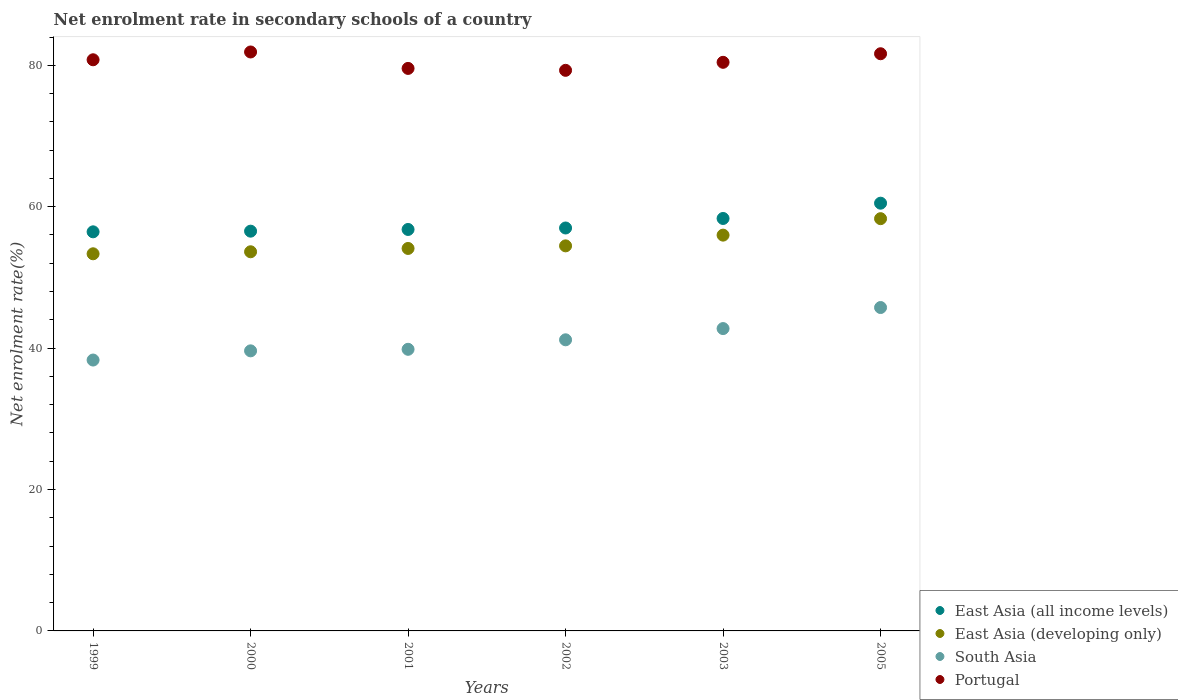How many different coloured dotlines are there?
Offer a terse response. 4. Is the number of dotlines equal to the number of legend labels?
Keep it short and to the point. Yes. What is the net enrolment rate in secondary schools in East Asia (developing only) in 2002?
Provide a succinct answer. 54.46. Across all years, what is the maximum net enrolment rate in secondary schools in East Asia (all income levels)?
Provide a short and direct response. 60.5. Across all years, what is the minimum net enrolment rate in secondary schools in East Asia (all income levels)?
Keep it short and to the point. 56.45. In which year was the net enrolment rate in secondary schools in East Asia (developing only) maximum?
Provide a short and direct response. 2005. What is the total net enrolment rate in secondary schools in South Asia in the graph?
Your answer should be very brief. 247.44. What is the difference between the net enrolment rate in secondary schools in South Asia in 1999 and that in 2005?
Ensure brevity in your answer.  -7.43. What is the difference between the net enrolment rate in secondary schools in East Asia (developing only) in 2002 and the net enrolment rate in secondary schools in East Asia (all income levels) in 2000?
Provide a short and direct response. -2.08. What is the average net enrolment rate in secondary schools in East Asia (developing only) per year?
Make the answer very short. 54.97. In the year 2000, what is the difference between the net enrolment rate in secondary schools in East Asia (developing only) and net enrolment rate in secondary schools in South Asia?
Keep it short and to the point. 14.01. What is the ratio of the net enrolment rate in secondary schools in Portugal in 2001 to that in 2002?
Your answer should be very brief. 1. Is the net enrolment rate in secondary schools in East Asia (developing only) in 2000 less than that in 2002?
Offer a terse response. Yes. Is the difference between the net enrolment rate in secondary schools in East Asia (developing only) in 2000 and 2002 greater than the difference between the net enrolment rate in secondary schools in South Asia in 2000 and 2002?
Provide a succinct answer. Yes. What is the difference between the highest and the second highest net enrolment rate in secondary schools in South Asia?
Ensure brevity in your answer.  2.98. What is the difference between the highest and the lowest net enrolment rate in secondary schools in South Asia?
Provide a short and direct response. 7.43. Is the sum of the net enrolment rate in secondary schools in East Asia (all income levels) in 2001 and 2003 greater than the maximum net enrolment rate in secondary schools in East Asia (developing only) across all years?
Offer a terse response. Yes. Is it the case that in every year, the sum of the net enrolment rate in secondary schools in Portugal and net enrolment rate in secondary schools in South Asia  is greater than the net enrolment rate in secondary schools in East Asia (all income levels)?
Offer a very short reply. Yes. Does the net enrolment rate in secondary schools in South Asia monotonically increase over the years?
Your answer should be compact. Yes. How many dotlines are there?
Provide a short and direct response. 4. How many years are there in the graph?
Keep it short and to the point. 6. Where does the legend appear in the graph?
Provide a succinct answer. Bottom right. What is the title of the graph?
Your answer should be very brief. Net enrolment rate in secondary schools of a country. Does "Middle East & North Africa (all income levels)" appear as one of the legend labels in the graph?
Offer a very short reply. No. What is the label or title of the Y-axis?
Offer a very short reply. Net enrolment rate(%). What is the Net enrolment rate(%) of East Asia (all income levels) in 1999?
Provide a succinct answer. 56.45. What is the Net enrolment rate(%) in East Asia (developing only) in 1999?
Your response must be concise. 53.34. What is the Net enrolment rate(%) in South Asia in 1999?
Your answer should be compact. 38.31. What is the Net enrolment rate(%) of Portugal in 1999?
Offer a very short reply. 80.78. What is the Net enrolment rate(%) of East Asia (all income levels) in 2000?
Give a very brief answer. 56.54. What is the Net enrolment rate(%) of East Asia (developing only) in 2000?
Provide a short and direct response. 53.63. What is the Net enrolment rate(%) of South Asia in 2000?
Make the answer very short. 39.61. What is the Net enrolment rate(%) in Portugal in 2000?
Provide a short and direct response. 81.89. What is the Net enrolment rate(%) in East Asia (all income levels) in 2001?
Your answer should be very brief. 56.78. What is the Net enrolment rate(%) in East Asia (developing only) in 2001?
Offer a terse response. 54.1. What is the Net enrolment rate(%) of South Asia in 2001?
Provide a short and direct response. 39.83. What is the Net enrolment rate(%) of Portugal in 2001?
Your answer should be compact. 79.56. What is the Net enrolment rate(%) in East Asia (all income levels) in 2002?
Your answer should be very brief. 56.99. What is the Net enrolment rate(%) in East Asia (developing only) in 2002?
Offer a very short reply. 54.46. What is the Net enrolment rate(%) in South Asia in 2002?
Ensure brevity in your answer.  41.18. What is the Net enrolment rate(%) of Portugal in 2002?
Offer a terse response. 79.29. What is the Net enrolment rate(%) in East Asia (all income levels) in 2003?
Keep it short and to the point. 58.34. What is the Net enrolment rate(%) in East Asia (developing only) in 2003?
Your answer should be very brief. 55.98. What is the Net enrolment rate(%) in South Asia in 2003?
Provide a succinct answer. 42.76. What is the Net enrolment rate(%) of Portugal in 2003?
Provide a succinct answer. 80.42. What is the Net enrolment rate(%) of East Asia (all income levels) in 2005?
Your response must be concise. 60.5. What is the Net enrolment rate(%) in East Asia (developing only) in 2005?
Your answer should be very brief. 58.31. What is the Net enrolment rate(%) in South Asia in 2005?
Ensure brevity in your answer.  45.74. What is the Net enrolment rate(%) of Portugal in 2005?
Provide a short and direct response. 81.64. Across all years, what is the maximum Net enrolment rate(%) in East Asia (all income levels)?
Keep it short and to the point. 60.5. Across all years, what is the maximum Net enrolment rate(%) in East Asia (developing only)?
Ensure brevity in your answer.  58.31. Across all years, what is the maximum Net enrolment rate(%) of South Asia?
Ensure brevity in your answer.  45.74. Across all years, what is the maximum Net enrolment rate(%) in Portugal?
Make the answer very short. 81.89. Across all years, what is the minimum Net enrolment rate(%) in East Asia (all income levels)?
Offer a very short reply. 56.45. Across all years, what is the minimum Net enrolment rate(%) of East Asia (developing only)?
Keep it short and to the point. 53.34. Across all years, what is the minimum Net enrolment rate(%) in South Asia?
Provide a short and direct response. 38.31. Across all years, what is the minimum Net enrolment rate(%) in Portugal?
Ensure brevity in your answer.  79.29. What is the total Net enrolment rate(%) in East Asia (all income levels) in the graph?
Offer a very short reply. 345.6. What is the total Net enrolment rate(%) in East Asia (developing only) in the graph?
Provide a succinct answer. 329.82. What is the total Net enrolment rate(%) in South Asia in the graph?
Offer a very short reply. 247.44. What is the total Net enrolment rate(%) in Portugal in the graph?
Keep it short and to the point. 483.58. What is the difference between the Net enrolment rate(%) of East Asia (all income levels) in 1999 and that in 2000?
Provide a succinct answer. -0.09. What is the difference between the Net enrolment rate(%) in East Asia (developing only) in 1999 and that in 2000?
Offer a terse response. -0.29. What is the difference between the Net enrolment rate(%) in South Asia in 1999 and that in 2000?
Your response must be concise. -1.3. What is the difference between the Net enrolment rate(%) in Portugal in 1999 and that in 2000?
Make the answer very short. -1.1. What is the difference between the Net enrolment rate(%) in East Asia (all income levels) in 1999 and that in 2001?
Provide a short and direct response. -0.33. What is the difference between the Net enrolment rate(%) in East Asia (developing only) in 1999 and that in 2001?
Give a very brief answer. -0.76. What is the difference between the Net enrolment rate(%) of South Asia in 1999 and that in 2001?
Your response must be concise. -1.52. What is the difference between the Net enrolment rate(%) of Portugal in 1999 and that in 2001?
Give a very brief answer. 1.22. What is the difference between the Net enrolment rate(%) of East Asia (all income levels) in 1999 and that in 2002?
Ensure brevity in your answer.  -0.54. What is the difference between the Net enrolment rate(%) of East Asia (developing only) in 1999 and that in 2002?
Your response must be concise. -1.12. What is the difference between the Net enrolment rate(%) of South Asia in 1999 and that in 2002?
Provide a short and direct response. -2.86. What is the difference between the Net enrolment rate(%) in Portugal in 1999 and that in 2002?
Give a very brief answer. 1.49. What is the difference between the Net enrolment rate(%) of East Asia (all income levels) in 1999 and that in 2003?
Offer a very short reply. -1.89. What is the difference between the Net enrolment rate(%) in East Asia (developing only) in 1999 and that in 2003?
Your answer should be very brief. -2.64. What is the difference between the Net enrolment rate(%) of South Asia in 1999 and that in 2003?
Your answer should be compact. -4.45. What is the difference between the Net enrolment rate(%) in Portugal in 1999 and that in 2003?
Give a very brief answer. 0.36. What is the difference between the Net enrolment rate(%) in East Asia (all income levels) in 1999 and that in 2005?
Your response must be concise. -4.05. What is the difference between the Net enrolment rate(%) of East Asia (developing only) in 1999 and that in 2005?
Offer a very short reply. -4.97. What is the difference between the Net enrolment rate(%) in South Asia in 1999 and that in 2005?
Provide a succinct answer. -7.43. What is the difference between the Net enrolment rate(%) of Portugal in 1999 and that in 2005?
Your answer should be very brief. -0.85. What is the difference between the Net enrolment rate(%) of East Asia (all income levels) in 2000 and that in 2001?
Provide a short and direct response. -0.24. What is the difference between the Net enrolment rate(%) of East Asia (developing only) in 2000 and that in 2001?
Offer a very short reply. -0.47. What is the difference between the Net enrolment rate(%) of South Asia in 2000 and that in 2001?
Keep it short and to the point. -0.22. What is the difference between the Net enrolment rate(%) of Portugal in 2000 and that in 2001?
Your answer should be compact. 2.33. What is the difference between the Net enrolment rate(%) in East Asia (all income levels) in 2000 and that in 2002?
Keep it short and to the point. -0.45. What is the difference between the Net enrolment rate(%) in East Asia (developing only) in 2000 and that in 2002?
Your response must be concise. -0.84. What is the difference between the Net enrolment rate(%) of South Asia in 2000 and that in 2002?
Offer a terse response. -1.56. What is the difference between the Net enrolment rate(%) in Portugal in 2000 and that in 2002?
Offer a terse response. 2.6. What is the difference between the Net enrolment rate(%) in East Asia (all income levels) in 2000 and that in 2003?
Give a very brief answer. -1.8. What is the difference between the Net enrolment rate(%) of East Asia (developing only) in 2000 and that in 2003?
Offer a terse response. -2.35. What is the difference between the Net enrolment rate(%) of South Asia in 2000 and that in 2003?
Your answer should be very brief. -3.15. What is the difference between the Net enrolment rate(%) of Portugal in 2000 and that in 2003?
Provide a succinct answer. 1.46. What is the difference between the Net enrolment rate(%) of East Asia (all income levels) in 2000 and that in 2005?
Your response must be concise. -3.96. What is the difference between the Net enrolment rate(%) of East Asia (developing only) in 2000 and that in 2005?
Your answer should be compact. -4.68. What is the difference between the Net enrolment rate(%) in South Asia in 2000 and that in 2005?
Your response must be concise. -6.13. What is the difference between the Net enrolment rate(%) in East Asia (all income levels) in 2001 and that in 2002?
Your answer should be very brief. -0.21. What is the difference between the Net enrolment rate(%) in East Asia (developing only) in 2001 and that in 2002?
Offer a terse response. -0.37. What is the difference between the Net enrolment rate(%) of South Asia in 2001 and that in 2002?
Keep it short and to the point. -1.34. What is the difference between the Net enrolment rate(%) of Portugal in 2001 and that in 2002?
Your response must be concise. 0.27. What is the difference between the Net enrolment rate(%) of East Asia (all income levels) in 2001 and that in 2003?
Offer a very short reply. -1.55. What is the difference between the Net enrolment rate(%) of East Asia (developing only) in 2001 and that in 2003?
Keep it short and to the point. -1.88. What is the difference between the Net enrolment rate(%) in South Asia in 2001 and that in 2003?
Provide a succinct answer. -2.93. What is the difference between the Net enrolment rate(%) in Portugal in 2001 and that in 2003?
Your answer should be very brief. -0.86. What is the difference between the Net enrolment rate(%) in East Asia (all income levels) in 2001 and that in 2005?
Your answer should be very brief. -3.72. What is the difference between the Net enrolment rate(%) of East Asia (developing only) in 2001 and that in 2005?
Make the answer very short. -4.21. What is the difference between the Net enrolment rate(%) of South Asia in 2001 and that in 2005?
Make the answer very short. -5.91. What is the difference between the Net enrolment rate(%) in Portugal in 2001 and that in 2005?
Your answer should be very brief. -2.08. What is the difference between the Net enrolment rate(%) of East Asia (all income levels) in 2002 and that in 2003?
Offer a very short reply. -1.35. What is the difference between the Net enrolment rate(%) of East Asia (developing only) in 2002 and that in 2003?
Ensure brevity in your answer.  -1.52. What is the difference between the Net enrolment rate(%) of South Asia in 2002 and that in 2003?
Keep it short and to the point. -1.59. What is the difference between the Net enrolment rate(%) in Portugal in 2002 and that in 2003?
Give a very brief answer. -1.13. What is the difference between the Net enrolment rate(%) in East Asia (all income levels) in 2002 and that in 2005?
Your response must be concise. -3.51. What is the difference between the Net enrolment rate(%) in East Asia (developing only) in 2002 and that in 2005?
Give a very brief answer. -3.85. What is the difference between the Net enrolment rate(%) of South Asia in 2002 and that in 2005?
Ensure brevity in your answer.  -4.57. What is the difference between the Net enrolment rate(%) in Portugal in 2002 and that in 2005?
Keep it short and to the point. -2.35. What is the difference between the Net enrolment rate(%) in East Asia (all income levels) in 2003 and that in 2005?
Your answer should be compact. -2.16. What is the difference between the Net enrolment rate(%) of East Asia (developing only) in 2003 and that in 2005?
Provide a succinct answer. -2.33. What is the difference between the Net enrolment rate(%) in South Asia in 2003 and that in 2005?
Offer a terse response. -2.98. What is the difference between the Net enrolment rate(%) in Portugal in 2003 and that in 2005?
Provide a succinct answer. -1.21. What is the difference between the Net enrolment rate(%) in East Asia (all income levels) in 1999 and the Net enrolment rate(%) in East Asia (developing only) in 2000?
Offer a terse response. 2.82. What is the difference between the Net enrolment rate(%) in East Asia (all income levels) in 1999 and the Net enrolment rate(%) in South Asia in 2000?
Your answer should be very brief. 16.83. What is the difference between the Net enrolment rate(%) of East Asia (all income levels) in 1999 and the Net enrolment rate(%) of Portugal in 2000?
Your answer should be compact. -25.44. What is the difference between the Net enrolment rate(%) of East Asia (developing only) in 1999 and the Net enrolment rate(%) of South Asia in 2000?
Offer a terse response. 13.73. What is the difference between the Net enrolment rate(%) in East Asia (developing only) in 1999 and the Net enrolment rate(%) in Portugal in 2000?
Provide a succinct answer. -28.54. What is the difference between the Net enrolment rate(%) of South Asia in 1999 and the Net enrolment rate(%) of Portugal in 2000?
Your answer should be very brief. -43.57. What is the difference between the Net enrolment rate(%) in East Asia (all income levels) in 1999 and the Net enrolment rate(%) in East Asia (developing only) in 2001?
Provide a succinct answer. 2.35. What is the difference between the Net enrolment rate(%) of East Asia (all income levels) in 1999 and the Net enrolment rate(%) of South Asia in 2001?
Give a very brief answer. 16.62. What is the difference between the Net enrolment rate(%) in East Asia (all income levels) in 1999 and the Net enrolment rate(%) in Portugal in 2001?
Your response must be concise. -23.11. What is the difference between the Net enrolment rate(%) in East Asia (developing only) in 1999 and the Net enrolment rate(%) in South Asia in 2001?
Offer a terse response. 13.51. What is the difference between the Net enrolment rate(%) of East Asia (developing only) in 1999 and the Net enrolment rate(%) of Portugal in 2001?
Ensure brevity in your answer.  -26.22. What is the difference between the Net enrolment rate(%) of South Asia in 1999 and the Net enrolment rate(%) of Portugal in 2001?
Provide a succinct answer. -41.25. What is the difference between the Net enrolment rate(%) of East Asia (all income levels) in 1999 and the Net enrolment rate(%) of East Asia (developing only) in 2002?
Keep it short and to the point. 1.99. What is the difference between the Net enrolment rate(%) in East Asia (all income levels) in 1999 and the Net enrolment rate(%) in South Asia in 2002?
Give a very brief answer. 15.27. What is the difference between the Net enrolment rate(%) in East Asia (all income levels) in 1999 and the Net enrolment rate(%) in Portugal in 2002?
Keep it short and to the point. -22.84. What is the difference between the Net enrolment rate(%) in East Asia (developing only) in 1999 and the Net enrolment rate(%) in South Asia in 2002?
Your answer should be compact. 12.17. What is the difference between the Net enrolment rate(%) in East Asia (developing only) in 1999 and the Net enrolment rate(%) in Portugal in 2002?
Offer a terse response. -25.95. What is the difference between the Net enrolment rate(%) in South Asia in 1999 and the Net enrolment rate(%) in Portugal in 2002?
Keep it short and to the point. -40.98. What is the difference between the Net enrolment rate(%) of East Asia (all income levels) in 1999 and the Net enrolment rate(%) of East Asia (developing only) in 2003?
Offer a terse response. 0.47. What is the difference between the Net enrolment rate(%) in East Asia (all income levels) in 1999 and the Net enrolment rate(%) in South Asia in 2003?
Provide a succinct answer. 13.68. What is the difference between the Net enrolment rate(%) of East Asia (all income levels) in 1999 and the Net enrolment rate(%) of Portugal in 2003?
Make the answer very short. -23.98. What is the difference between the Net enrolment rate(%) of East Asia (developing only) in 1999 and the Net enrolment rate(%) of South Asia in 2003?
Offer a very short reply. 10.58. What is the difference between the Net enrolment rate(%) in East Asia (developing only) in 1999 and the Net enrolment rate(%) in Portugal in 2003?
Keep it short and to the point. -27.08. What is the difference between the Net enrolment rate(%) in South Asia in 1999 and the Net enrolment rate(%) in Portugal in 2003?
Your answer should be very brief. -42.11. What is the difference between the Net enrolment rate(%) in East Asia (all income levels) in 1999 and the Net enrolment rate(%) in East Asia (developing only) in 2005?
Keep it short and to the point. -1.86. What is the difference between the Net enrolment rate(%) of East Asia (all income levels) in 1999 and the Net enrolment rate(%) of South Asia in 2005?
Offer a very short reply. 10.71. What is the difference between the Net enrolment rate(%) in East Asia (all income levels) in 1999 and the Net enrolment rate(%) in Portugal in 2005?
Your answer should be compact. -25.19. What is the difference between the Net enrolment rate(%) of East Asia (developing only) in 1999 and the Net enrolment rate(%) of South Asia in 2005?
Your answer should be very brief. 7.6. What is the difference between the Net enrolment rate(%) of East Asia (developing only) in 1999 and the Net enrolment rate(%) of Portugal in 2005?
Offer a very short reply. -28.29. What is the difference between the Net enrolment rate(%) in South Asia in 1999 and the Net enrolment rate(%) in Portugal in 2005?
Your response must be concise. -43.32. What is the difference between the Net enrolment rate(%) of East Asia (all income levels) in 2000 and the Net enrolment rate(%) of East Asia (developing only) in 2001?
Provide a succinct answer. 2.44. What is the difference between the Net enrolment rate(%) of East Asia (all income levels) in 2000 and the Net enrolment rate(%) of South Asia in 2001?
Provide a short and direct response. 16.71. What is the difference between the Net enrolment rate(%) of East Asia (all income levels) in 2000 and the Net enrolment rate(%) of Portugal in 2001?
Offer a very short reply. -23.02. What is the difference between the Net enrolment rate(%) of East Asia (developing only) in 2000 and the Net enrolment rate(%) of South Asia in 2001?
Offer a very short reply. 13.79. What is the difference between the Net enrolment rate(%) in East Asia (developing only) in 2000 and the Net enrolment rate(%) in Portugal in 2001?
Your answer should be very brief. -25.93. What is the difference between the Net enrolment rate(%) of South Asia in 2000 and the Net enrolment rate(%) of Portugal in 2001?
Offer a terse response. -39.95. What is the difference between the Net enrolment rate(%) in East Asia (all income levels) in 2000 and the Net enrolment rate(%) in East Asia (developing only) in 2002?
Your answer should be very brief. 2.08. What is the difference between the Net enrolment rate(%) of East Asia (all income levels) in 2000 and the Net enrolment rate(%) of South Asia in 2002?
Offer a very short reply. 15.37. What is the difference between the Net enrolment rate(%) of East Asia (all income levels) in 2000 and the Net enrolment rate(%) of Portugal in 2002?
Offer a terse response. -22.75. What is the difference between the Net enrolment rate(%) in East Asia (developing only) in 2000 and the Net enrolment rate(%) in South Asia in 2002?
Give a very brief answer. 12.45. What is the difference between the Net enrolment rate(%) in East Asia (developing only) in 2000 and the Net enrolment rate(%) in Portugal in 2002?
Provide a short and direct response. -25.66. What is the difference between the Net enrolment rate(%) of South Asia in 2000 and the Net enrolment rate(%) of Portugal in 2002?
Your answer should be compact. -39.68. What is the difference between the Net enrolment rate(%) in East Asia (all income levels) in 2000 and the Net enrolment rate(%) in East Asia (developing only) in 2003?
Your answer should be very brief. 0.56. What is the difference between the Net enrolment rate(%) of East Asia (all income levels) in 2000 and the Net enrolment rate(%) of South Asia in 2003?
Your answer should be very brief. 13.78. What is the difference between the Net enrolment rate(%) in East Asia (all income levels) in 2000 and the Net enrolment rate(%) in Portugal in 2003?
Your response must be concise. -23.88. What is the difference between the Net enrolment rate(%) in East Asia (developing only) in 2000 and the Net enrolment rate(%) in South Asia in 2003?
Give a very brief answer. 10.86. What is the difference between the Net enrolment rate(%) in East Asia (developing only) in 2000 and the Net enrolment rate(%) in Portugal in 2003?
Offer a terse response. -26.8. What is the difference between the Net enrolment rate(%) of South Asia in 2000 and the Net enrolment rate(%) of Portugal in 2003?
Offer a very short reply. -40.81. What is the difference between the Net enrolment rate(%) of East Asia (all income levels) in 2000 and the Net enrolment rate(%) of East Asia (developing only) in 2005?
Offer a very short reply. -1.77. What is the difference between the Net enrolment rate(%) in East Asia (all income levels) in 2000 and the Net enrolment rate(%) in South Asia in 2005?
Provide a succinct answer. 10.8. What is the difference between the Net enrolment rate(%) in East Asia (all income levels) in 2000 and the Net enrolment rate(%) in Portugal in 2005?
Give a very brief answer. -25.1. What is the difference between the Net enrolment rate(%) in East Asia (developing only) in 2000 and the Net enrolment rate(%) in South Asia in 2005?
Provide a short and direct response. 7.89. What is the difference between the Net enrolment rate(%) of East Asia (developing only) in 2000 and the Net enrolment rate(%) of Portugal in 2005?
Your answer should be compact. -28.01. What is the difference between the Net enrolment rate(%) in South Asia in 2000 and the Net enrolment rate(%) in Portugal in 2005?
Your response must be concise. -42.02. What is the difference between the Net enrolment rate(%) in East Asia (all income levels) in 2001 and the Net enrolment rate(%) in East Asia (developing only) in 2002?
Keep it short and to the point. 2.32. What is the difference between the Net enrolment rate(%) in East Asia (all income levels) in 2001 and the Net enrolment rate(%) in South Asia in 2002?
Provide a short and direct response. 15.61. What is the difference between the Net enrolment rate(%) of East Asia (all income levels) in 2001 and the Net enrolment rate(%) of Portugal in 2002?
Provide a short and direct response. -22.51. What is the difference between the Net enrolment rate(%) of East Asia (developing only) in 2001 and the Net enrolment rate(%) of South Asia in 2002?
Your response must be concise. 12.92. What is the difference between the Net enrolment rate(%) of East Asia (developing only) in 2001 and the Net enrolment rate(%) of Portugal in 2002?
Your response must be concise. -25.19. What is the difference between the Net enrolment rate(%) in South Asia in 2001 and the Net enrolment rate(%) in Portugal in 2002?
Ensure brevity in your answer.  -39.46. What is the difference between the Net enrolment rate(%) in East Asia (all income levels) in 2001 and the Net enrolment rate(%) in East Asia (developing only) in 2003?
Your answer should be very brief. 0.8. What is the difference between the Net enrolment rate(%) in East Asia (all income levels) in 2001 and the Net enrolment rate(%) in South Asia in 2003?
Provide a succinct answer. 14.02. What is the difference between the Net enrolment rate(%) in East Asia (all income levels) in 2001 and the Net enrolment rate(%) in Portugal in 2003?
Provide a succinct answer. -23.64. What is the difference between the Net enrolment rate(%) of East Asia (developing only) in 2001 and the Net enrolment rate(%) of South Asia in 2003?
Your answer should be very brief. 11.33. What is the difference between the Net enrolment rate(%) in East Asia (developing only) in 2001 and the Net enrolment rate(%) in Portugal in 2003?
Offer a terse response. -26.33. What is the difference between the Net enrolment rate(%) in South Asia in 2001 and the Net enrolment rate(%) in Portugal in 2003?
Provide a short and direct response. -40.59. What is the difference between the Net enrolment rate(%) in East Asia (all income levels) in 2001 and the Net enrolment rate(%) in East Asia (developing only) in 2005?
Offer a terse response. -1.53. What is the difference between the Net enrolment rate(%) of East Asia (all income levels) in 2001 and the Net enrolment rate(%) of South Asia in 2005?
Ensure brevity in your answer.  11.04. What is the difference between the Net enrolment rate(%) of East Asia (all income levels) in 2001 and the Net enrolment rate(%) of Portugal in 2005?
Provide a succinct answer. -24.85. What is the difference between the Net enrolment rate(%) in East Asia (developing only) in 2001 and the Net enrolment rate(%) in South Asia in 2005?
Keep it short and to the point. 8.36. What is the difference between the Net enrolment rate(%) in East Asia (developing only) in 2001 and the Net enrolment rate(%) in Portugal in 2005?
Your answer should be very brief. -27.54. What is the difference between the Net enrolment rate(%) in South Asia in 2001 and the Net enrolment rate(%) in Portugal in 2005?
Keep it short and to the point. -41.8. What is the difference between the Net enrolment rate(%) of East Asia (all income levels) in 2002 and the Net enrolment rate(%) of East Asia (developing only) in 2003?
Give a very brief answer. 1.01. What is the difference between the Net enrolment rate(%) in East Asia (all income levels) in 2002 and the Net enrolment rate(%) in South Asia in 2003?
Provide a short and direct response. 14.23. What is the difference between the Net enrolment rate(%) of East Asia (all income levels) in 2002 and the Net enrolment rate(%) of Portugal in 2003?
Your answer should be very brief. -23.43. What is the difference between the Net enrolment rate(%) in East Asia (developing only) in 2002 and the Net enrolment rate(%) in South Asia in 2003?
Your response must be concise. 11.7. What is the difference between the Net enrolment rate(%) of East Asia (developing only) in 2002 and the Net enrolment rate(%) of Portugal in 2003?
Your answer should be compact. -25.96. What is the difference between the Net enrolment rate(%) in South Asia in 2002 and the Net enrolment rate(%) in Portugal in 2003?
Keep it short and to the point. -39.25. What is the difference between the Net enrolment rate(%) of East Asia (all income levels) in 2002 and the Net enrolment rate(%) of East Asia (developing only) in 2005?
Give a very brief answer. -1.32. What is the difference between the Net enrolment rate(%) in East Asia (all income levels) in 2002 and the Net enrolment rate(%) in South Asia in 2005?
Offer a terse response. 11.25. What is the difference between the Net enrolment rate(%) of East Asia (all income levels) in 2002 and the Net enrolment rate(%) of Portugal in 2005?
Your answer should be compact. -24.65. What is the difference between the Net enrolment rate(%) in East Asia (developing only) in 2002 and the Net enrolment rate(%) in South Asia in 2005?
Offer a terse response. 8.72. What is the difference between the Net enrolment rate(%) in East Asia (developing only) in 2002 and the Net enrolment rate(%) in Portugal in 2005?
Provide a succinct answer. -27.17. What is the difference between the Net enrolment rate(%) in South Asia in 2002 and the Net enrolment rate(%) in Portugal in 2005?
Provide a succinct answer. -40.46. What is the difference between the Net enrolment rate(%) in East Asia (all income levels) in 2003 and the Net enrolment rate(%) in East Asia (developing only) in 2005?
Give a very brief answer. 0.03. What is the difference between the Net enrolment rate(%) in East Asia (all income levels) in 2003 and the Net enrolment rate(%) in South Asia in 2005?
Your answer should be very brief. 12.6. What is the difference between the Net enrolment rate(%) in East Asia (all income levels) in 2003 and the Net enrolment rate(%) in Portugal in 2005?
Your response must be concise. -23.3. What is the difference between the Net enrolment rate(%) of East Asia (developing only) in 2003 and the Net enrolment rate(%) of South Asia in 2005?
Your answer should be very brief. 10.24. What is the difference between the Net enrolment rate(%) of East Asia (developing only) in 2003 and the Net enrolment rate(%) of Portugal in 2005?
Make the answer very short. -25.66. What is the difference between the Net enrolment rate(%) of South Asia in 2003 and the Net enrolment rate(%) of Portugal in 2005?
Provide a short and direct response. -38.87. What is the average Net enrolment rate(%) of East Asia (all income levels) per year?
Your answer should be very brief. 57.6. What is the average Net enrolment rate(%) of East Asia (developing only) per year?
Provide a short and direct response. 54.97. What is the average Net enrolment rate(%) in South Asia per year?
Ensure brevity in your answer.  41.24. What is the average Net enrolment rate(%) of Portugal per year?
Give a very brief answer. 80.6. In the year 1999, what is the difference between the Net enrolment rate(%) in East Asia (all income levels) and Net enrolment rate(%) in East Asia (developing only)?
Provide a succinct answer. 3.11. In the year 1999, what is the difference between the Net enrolment rate(%) of East Asia (all income levels) and Net enrolment rate(%) of South Asia?
Keep it short and to the point. 18.13. In the year 1999, what is the difference between the Net enrolment rate(%) of East Asia (all income levels) and Net enrolment rate(%) of Portugal?
Give a very brief answer. -24.34. In the year 1999, what is the difference between the Net enrolment rate(%) of East Asia (developing only) and Net enrolment rate(%) of South Asia?
Keep it short and to the point. 15.03. In the year 1999, what is the difference between the Net enrolment rate(%) of East Asia (developing only) and Net enrolment rate(%) of Portugal?
Provide a short and direct response. -27.44. In the year 1999, what is the difference between the Net enrolment rate(%) in South Asia and Net enrolment rate(%) in Portugal?
Your answer should be very brief. -42.47. In the year 2000, what is the difference between the Net enrolment rate(%) of East Asia (all income levels) and Net enrolment rate(%) of East Asia (developing only)?
Offer a very short reply. 2.91. In the year 2000, what is the difference between the Net enrolment rate(%) of East Asia (all income levels) and Net enrolment rate(%) of South Asia?
Your response must be concise. 16.93. In the year 2000, what is the difference between the Net enrolment rate(%) in East Asia (all income levels) and Net enrolment rate(%) in Portugal?
Offer a terse response. -25.35. In the year 2000, what is the difference between the Net enrolment rate(%) in East Asia (developing only) and Net enrolment rate(%) in South Asia?
Provide a succinct answer. 14.01. In the year 2000, what is the difference between the Net enrolment rate(%) of East Asia (developing only) and Net enrolment rate(%) of Portugal?
Offer a terse response. -28.26. In the year 2000, what is the difference between the Net enrolment rate(%) in South Asia and Net enrolment rate(%) in Portugal?
Provide a succinct answer. -42.27. In the year 2001, what is the difference between the Net enrolment rate(%) in East Asia (all income levels) and Net enrolment rate(%) in East Asia (developing only)?
Your response must be concise. 2.69. In the year 2001, what is the difference between the Net enrolment rate(%) in East Asia (all income levels) and Net enrolment rate(%) in South Asia?
Give a very brief answer. 16.95. In the year 2001, what is the difference between the Net enrolment rate(%) of East Asia (all income levels) and Net enrolment rate(%) of Portugal?
Make the answer very short. -22.78. In the year 2001, what is the difference between the Net enrolment rate(%) of East Asia (developing only) and Net enrolment rate(%) of South Asia?
Give a very brief answer. 14.26. In the year 2001, what is the difference between the Net enrolment rate(%) in East Asia (developing only) and Net enrolment rate(%) in Portugal?
Keep it short and to the point. -25.46. In the year 2001, what is the difference between the Net enrolment rate(%) in South Asia and Net enrolment rate(%) in Portugal?
Make the answer very short. -39.73. In the year 2002, what is the difference between the Net enrolment rate(%) of East Asia (all income levels) and Net enrolment rate(%) of East Asia (developing only)?
Your answer should be very brief. 2.53. In the year 2002, what is the difference between the Net enrolment rate(%) in East Asia (all income levels) and Net enrolment rate(%) in South Asia?
Make the answer very short. 15.81. In the year 2002, what is the difference between the Net enrolment rate(%) in East Asia (all income levels) and Net enrolment rate(%) in Portugal?
Give a very brief answer. -22.3. In the year 2002, what is the difference between the Net enrolment rate(%) of East Asia (developing only) and Net enrolment rate(%) of South Asia?
Your answer should be compact. 13.29. In the year 2002, what is the difference between the Net enrolment rate(%) of East Asia (developing only) and Net enrolment rate(%) of Portugal?
Provide a short and direct response. -24.83. In the year 2002, what is the difference between the Net enrolment rate(%) in South Asia and Net enrolment rate(%) in Portugal?
Provide a succinct answer. -38.12. In the year 2003, what is the difference between the Net enrolment rate(%) of East Asia (all income levels) and Net enrolment rate(%) of East Asia (developing only)?
Offer a very short reply. 2.36. In the year 2003, what is the difference between the Net enrolment rate(%) in East Asia (all income levels) and Net enrolment rate(%) in South Asia?
Offer a terse response. 15.57. In the year 2003, what is the difference between the Net enrolment rate(%) of East Asia (all income levels) and Net enrolment rate(%) of Portugal?
Ensure brevity in your answer.  -22.09. In the year 2003, what is the difference between the Net enrolment rate(%) of East Asia (developing only) and Net enrolment rate(%) of South Asia?
Provide a short and direct response. 13.22. In the year 2003, what is the difference between the Net enrolment rate(%) of East Asia (developing only) and Net enrolment rate(%) of Portugal?
Your answer should be very brief. -24.44. In the year 2003, what is the difference between the Net enrolment rate(%) in South Asia and Net enrolment rate(%) in Portugal?
Provide a short and direct response. -37.66. In the year 2005, what is the difference between the Net enrolment rate(%) in East Asia (all income levels) and Net enrolment rate(%) in East Asia (developing only)?
Offer a terse response. 2.19. In the year 2005, what is the difference between the Net enrolment rate(%) of East Asia (all income levels) and Net enrolment rate(%) of South Asia?
Provide a succinct answer. 14.76. In the year 2005, what is the difference between the Net enrolment rate(%) of East Asia (all income levels) and Net enrolment rate(%) of Portugal?
Make the answer very short. -21.14. In the year 2005, what is the difference between the Net enrolment rate(%) of East Asia (developing only) and Net enrolment rate(%) of South Asia?
Provide a short and direct response. 12.57. In the year 2005, what is the difference between the Net enrolment rate(%) in East Asia (developing only) and Net enrolment rate(%) in Portugal?
Provide a short and direct response. -23.33. In the year 2005, what is the difference between the Net enrolment rate(%) in South Asia and Net enrolment rate(%) in Portugal?
Your answer should be very brief. -35.9. What is the ratio of the Net enrolment rate(%) of East Asia (all income levels) in 1999 to that in 2000?
Provide a succinct answer. 1. What is the ratio of the Net enrolment rate(%) of East Asia (developing only) in 1999 to that in 2000?
Make the answer very short. 0.99. What is the ratio of the Net enrolment rate(%) in South Asia in 1999 to that in 2000?
Your answer should be compact. 0.97. What is the ratio of the Net enrolment rate(%) of Portugal in 1999 to that in 2000?
Your answer should be compact. 0.99. What is the ratio of the Net enrolment rate(%) of South Asia in 1999 to that in 2001?
Provide a succinct answer. 0.96. What is the ratio of the Net enrolment rate(%) of Portugal in 1999 to that in 2001?
Your answer should be compact. 1.02. What is the ratio of the Net enrolment rate(%) in East Asia (all income levels) in 1999 to that in 2002?
Your answer should be compact. 0.99. What is the ratio of the Net enrolment rate(%) in East Asia (developing only) in 1999 to that in 2002?
Provide a short and direct response. 0.98. What is the ratio of the Net enrolment rate(%) of South Asia in 1999 to that in 2002?
Your answer should be compact. 0.93. What is the ratio of the Net enrolment rate(%) of Portugal in 1999 to that in 2002?
Provide a succinct answer. 1.02. What is the ratio of the Net enrolment rate(%) of East Asia (all income levels) in 1999 to that in 2003?
Your response must be concise. 0.97. What is the ratio of the Net enrolment rate(%) in East Asia (developing only) in 1999 to that in 2003?
Provide a short and direct response. 0.95. What is the ratio of the Net enrolment rate(%) of South Asia in 1999 to that in 2003?
Make the answer very short. 0.9. What is the ratio of the Net enrolment rate(%) in Portugal in 1999 to that in 2003?
Provide a short and direct response. 1. What is the ratio of the Net enrolment rate(%) in East Asia (all income levels) in 1999 to that in 2005?
Keep it short and to the point. 0.93. What is the ratio of the Net enrolment rate(%) in East Asia (developing only) in 1999 to that in 2005?
Make the answer very short. 0.91. What is the ratio of the Net enrolment rate(%) in South Asia in 1999 to that in 2005?
Give a very brief answer. 0.84. What is the ratio of the Net enrolment rate(%) of Portugal in 1999 to that in 2005?
Your answer should be compact. 0.99. What is the ratio of the Net enrolment rate(%) in East Asia (all income levels) in 2000 to that in 2001?
Ensure brevity in your answer.  1. What is the ratio of the Net enrolment rate(%) of South Asia in 2000 to that in 2001?
Your response must be concise. 0.99. What is the ratio of the Net enrolment rate(%) of Portugal in 2000 to that in 2001?
Your response must be concise. 1.03. What is the ratio of the Net enrolment rate(%) in East Asia (developing only) in 2000 to that in 2002?
Your answer should be very brief. 0.98. What is the ratio of the Net enrolment rate(%) of South Asia in 2000 to that in 2002?
Offer a very short reply. 0.96. What is the ratio of the Net enrolment rate(%) in Portugal in 2000 to that in 2002?
Your answer should be compact. 1.03. What is the ratio of the Net enrolment rate(%) of East Asia (all income levels) in 2000 to that in 2003?
Make the answer very short. 0.97. What is the ratio of the Net enrolment rate(%) in East Asia (developing only) in 2000 to that in 2003?
Your answer should be very brief. 0.96. What is the ratio of the Net enrolment rate(%) of South Asia in 2000 to that in 2003?
Offer a very short reply. 0.93. What is the ratio of the Net enrolment rate(%) in Portugal in 2000 to that in 2003?
Provide a succinct answer. 1.02. What is the ratio of the Net enrolment rate(%) of East Asia (all income levels) in 2000 to that in 2005?
Make the answer very short. 0.93. What is the ratio of the Net enrolment rate(%) of East Asia (developing only) in 2000 to that in 2005?
Provide a succinct answer. 0.92. What is the ratio of the Net enrolment rate(%) of South Asia in 2000 to that in 2005?
Your answer should be very brief. 0.87. What is the ratio of the Net enrolment rate(%) in East Asia (all income levels) in 2001 to that in 2002?
Offer a very short reply. 1. What is the ratio of the Net enrolment rate(%) of South Asia in 2001 to that in 2002?
Your answer should be very brief. 0.97. What is the ratio of the Net enrolment rate(%) in East Asia (all income levels) in 2001 to that in 2003?
Give a very brief answer. 0.97. What is the ratio of the Net enrolment rate(%) of East Asia (developing only) in 2001 to that in 2003?
Your response must be concise. 0.97. What is the ratio of the Net enrolment rate(%) of South Asia in 2001 to that in 2003?
Provide a succinct answer. 0.93. What is the ratio of the Net enrolment rate(%) in Portugal in 2001 to that in 2003?
Your answer should be compact. 0.99. What is the ratio of the Net enrolment rate(%) in East Asia (all income levels) in 2001 to that in 2005?
Keep it short and to the point. 0.94. What is the ratio of the Net enrolment rate(%) in East Asia (developing only) in 2001 to that in 2005?
Offer a terse response. 0.93. What is the ratio of the Net enrolment rate(%) of South Asia in 2001 to that in 2005?
Offer a very short reply. 0.87. What is the ratio of the Net enrolment rate(%) in Portugal in 2001 to that in 2005?
Give a very brief answer. 0.97. What is the ratio of the Net enrolment rate(%) of East Asia (all income levels) in 2002 to that in 2003?
Ensure brevity in your answer.  0.98. What is the ratio of the Net enrolment rate(%) in East Asia (developing only) in 2002 to that in 2003?
Make the answer very short. 0.97. What is the ratio of the Net enrolment rate(%) of South Asia in 2002 to that in 2003?
Keep it short and to the point. 0.96. What is the ratio of the Net enrolment rate(%) of Portugal in 2002 to that in 2003?
Your answer should be very brief. 0.99. What is the ratio of the Net enrolment rate(%) in East Asia (all income levels) in 2002 to that in 2005?
Ensure brevity in your answer.  0.94. What is the ratio of the Net enrolment rate(%) of East Asia (developing only) in 2002 to that in 2005?
Your answer should be compact. 0.93. What is the ratio of the Net enrolment rate(%) of South Asia in 2002 to that in 2005?
Make the answer very short. 0.9. What is the ratio of the Net enrolment rate(%) in Portugal in 2002 to that in 2005?
Ensure brevity in your answer.  0.97. What is the ratio of the Net enrolment rate(%) in East Asia (developing only) in 2003 to that in 2005?
Ensure brevity in your answer.  0.96. What is the ratio of the Net enrolment rate(%) of South Asia in 2003 to that in 2005?
Offer a very short reply. 0.93. What is the ratio of the Net enrolment rate(%) of Portugal in 2003 to that in 2005?
Ensure brevity in your answer.  0.99. What is the difference between the highest and the second highest Net enrolment rate(%) in East Asia (all income levels)?
Provide a short and direct response. 2.16. What is the difference between the highest and the second highest Net enrolment rate(%) of East Asia (developing only)?
Give a very brief answer. 2.33. What is the difference between the highest and the second highest Net enrolment rate(%) in South Asia?
Give a very brief answer. 2.98. What is the difference between the highest and the second highest Net enrolment rate(%) in Portugal?
Provide a short and direct response. 0.25. What is the difference between the highest and the lowest Net enrolment rate(%) of East Asia (all income levels)?
Offer a terse response. 4.05. What is the difference between the highest and the lowest Net enrolment rate(%) of East Asia (developing only)?
Offer a terse response. 4.97. What is the difference between the highest and the lowest Net enrolment rate(%) of South Asia?
Your response must be concise. 7.43. What is the difference between the highest and the lowest Net enrolment rate(%) in Portugal?
Offer a very short reply. 2.6. 